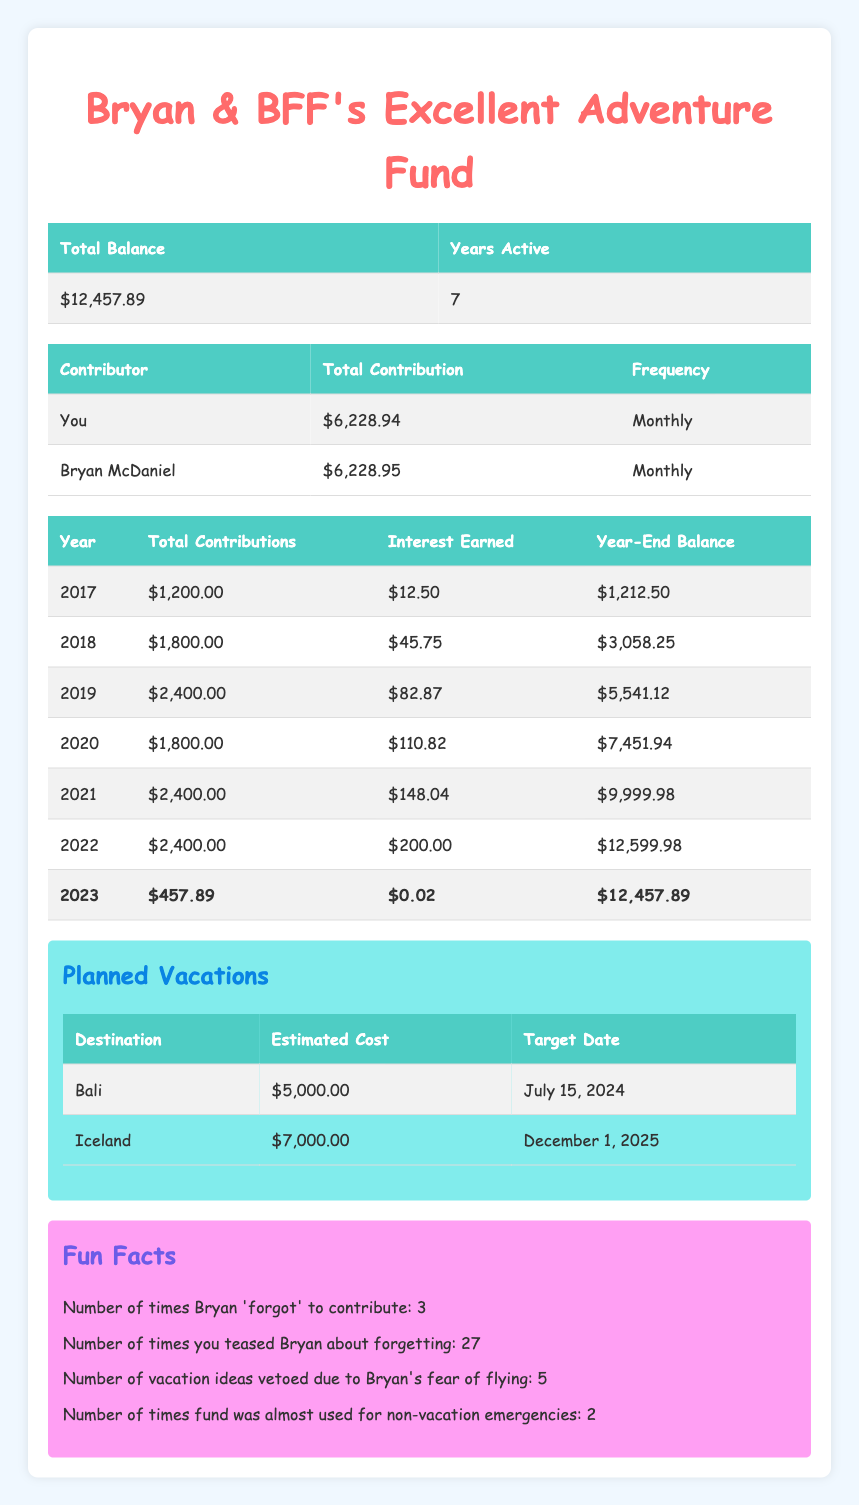What is the total balance of the vacation fund? The total balance can be found in the summary table under "Total Balance," which shows $12,457.89 for the fund.
Answer: $12,457.89 How many years has the vacation fund been active? The number of years active is stated in the summary table under "Years Active," which is 7 years.
Answer: 7 years What was the total contribution in 2021? The total contribution for 2021 can be found in the yearly breakdown table for that specific year, which shows a total contribution of $2,400.00.
Answer: $2,400.00 What is the average annual contribution over the years? The total contributions over 7 years can be calculated by summing each year's contributions: 1200 + 1800 + 2400 + 1800 + 2400 + 2400 + 457.89 = 12,857.89, and dividing by 7 gives an average of $1,837.55.
Answer: $1,837.55 Did Bryan contribute more than you? Bryan's total contribution is $6,228.95, which is slightly higher than your total contribution of $6,228.94.
Answer: Yes How much interest was earned in 2022? The interest earned for 2022 is listed in the yearly breakdown table, showing an amount of $200.00.
Answer: $200.00 What is the total estimated cost of the planned vacations? The estimated costs for planned vacations are $5,000.00 for Bali and $7,000.00 for Iceland, totaling $12,000.00 when summed together.
Answer: $12,000.00 How many times did Bryan forget to contribute? The fun facts section states that Bryan 'forgot' to contribute 3 times, according to the data presented.
Answer: 3 times What was the year-end balance for the fund in 2019? The year-end balance for 2019 can be found in the yearly breakdown table, which lists it as $5,541.12.
Answer: $5,541.12 How many vacation ideas were vetoed due to Bryan's fear of flying? According to the fun facts section, the number of vacation ideas vetoed is stated to be 5.
Answer: 5 